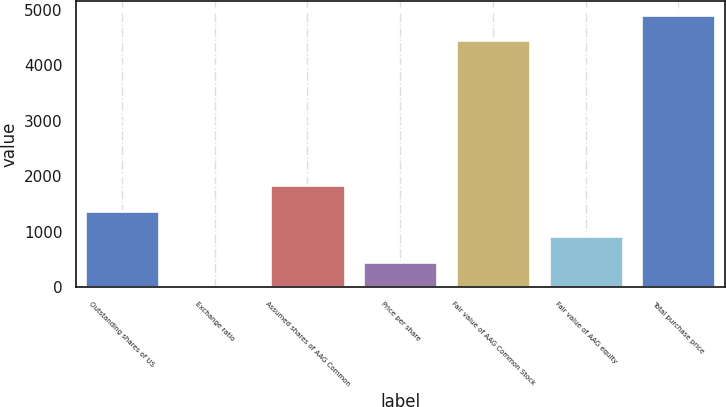Convert chart to OTSL. <chart><loc_0><loc_0><loc_500><loc_500><bar_chart><fcel>Outstanding shares of US<fcel>Exchange ratio<fcel>Assumed shares of AAG Common<fcel>Price per share<fcel>Fair value of AAG Common Stock<fcel>Fair value of AAG equity<fcel>Total purchase price<nl><fcel>1378.3<fcel>1<fcel>1837.4<fcel>460.1<fcel>4451<fcel>919.2<fcel>4910.1<nl></chart> 